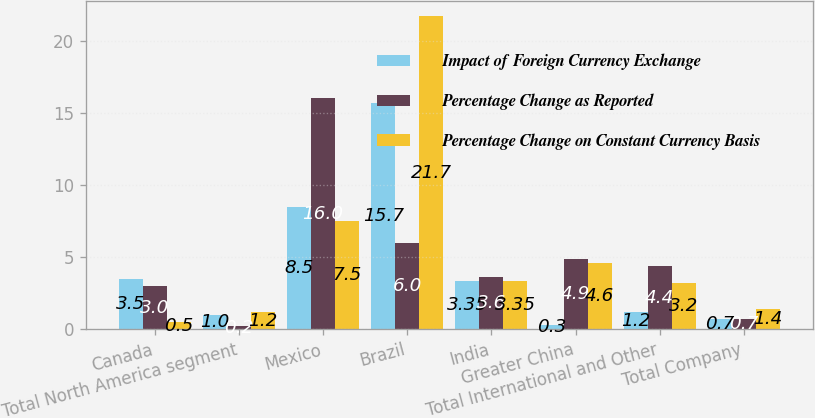Convert chart to OTSL. <chart><loc_0><loc_0><loc_500><loc_500><stacked_bar_chart><ecel><fcel>Canada<fcel>Total North America segment<fcel>Mexico<fcel>Brazil<fcel>India<fcel>Greater China<fcel>Total International and Other<fcel>Total Company<nl><fcel>Impact of Foreign Currency Exchange<fcel>3.5<fcel>1<fcel>8.5<fcel>15.7<fcel>3.35<fcel>0.3<fcel>1.2<fcel>0.7<nl><fcel>Percentage Change as Reported<fcel>3<fcel>0.2<fcel>16<fcel>6<fcel>3.6<fcel>4.9<fcel>4.4<fcel>0.7<nl><fcel>Percentage Change on Constant Currency Basis<fcel>0.5<fcel>1.2<fcel>7.5<fcel>21.7<fcel>3.35<fcel>4.6<fcel>3.2<fcel>1.4<nl></chart> 